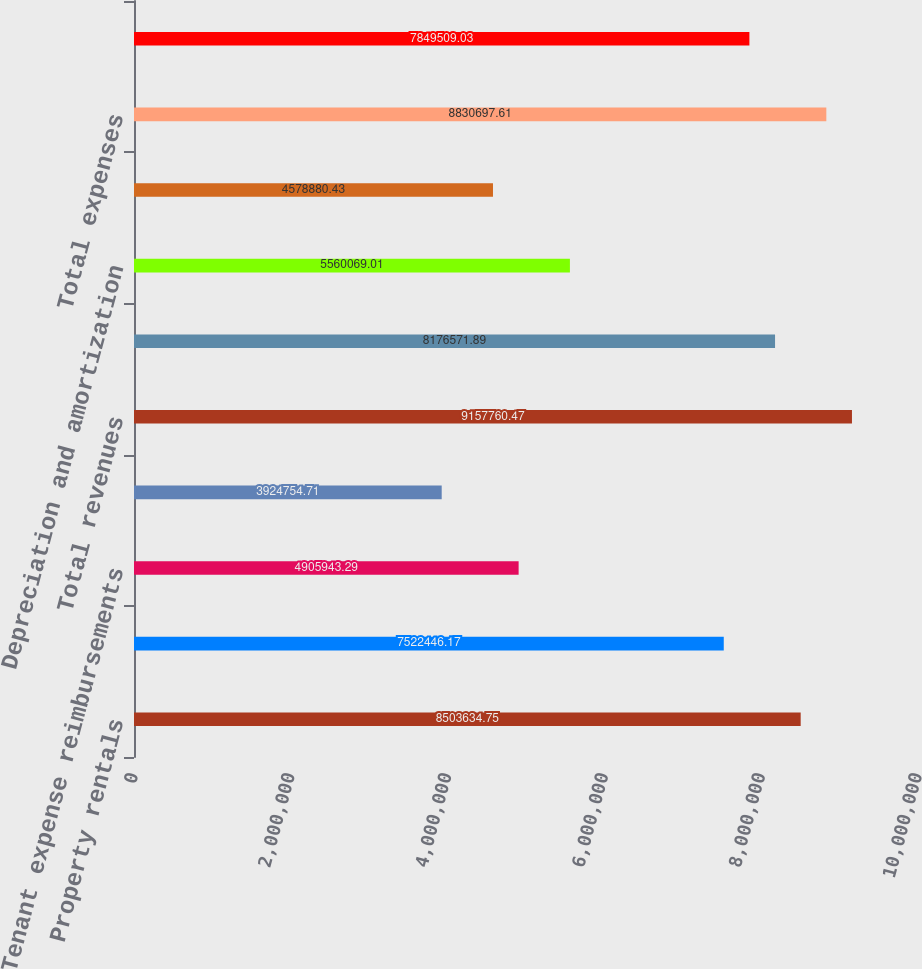Convert chart to OTSL. <chart><loc_0><loc_0><loc_500><loc_500><bar_chart><fcel>Property rentals<fcel>Temperature Controlled<fcel>Tenant expense reimbursements<fcel>Fee and other income<fcel>Total revenues<fcel>Operating<fcel>Depreciation and amortization<fcel>General and administrative<fcel>Total expenses<fcel>Operating income<nl><fcel>8.50363e+06<fcel>7.52245e+06<fcel>4.90594e+06<fcel>3.92475e+06<fcel>9.15776e+06<fcel>8.17657e+06<fcel>5.56007e+06<fcel>4.57888e+06<fcel>8.8307e+06<fcel>7.84951e+06<nl></chart> 